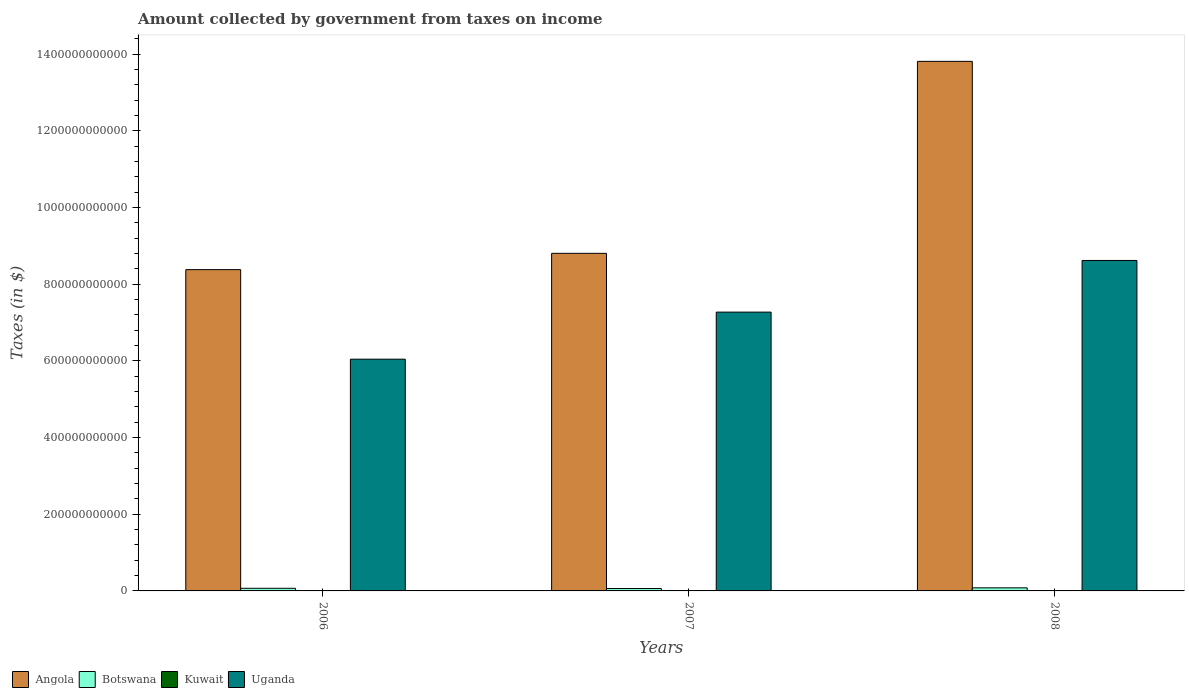Are the number of bars per tick equal to the number of legend labels?
Keep it short and to the point. Yes. What is the label of the 2nd group of bars from the left?
Keep it short and to the point. 2007. What is the amount collected by government from taxes on income in Botswana in 2006?
Offer a very short reply. 6.88e+09. Across all years, what is the maximum amount collected by government from taxes on income in Botswana?
Keep it short and to the point. 8.06e+09. Across all years, what is the minimum amount collected by government from taxes on income in Kuwait?
Your answer should be very brief. 8.20e+07. In which year was the amount collected by government from taxes on income in Botswana maximum?
Offer a terse response. 2008. In which year was the amount collected by government from taxes on income in Botswana minimum?
Keep it short and to the point. 2007. What is the total amount collected by government from taxes on income in Kuwait in the graph?
Give a very brief answer. 3.13e+08. What is the difference between the amount collected by government from taxes on income in Angola in 2007 and that in 2008?
Your answer should be very brief. -5.01e+11. What is the difference between the amount collected by government from taxes on income in Angola in 2008 and the amount collected by government from taxes on income in Kuwait in 2007?
Ensure brevity in your answer.  1.38e+12. What is the average amount collected by government from taxes on income in Botswana per year?
Provide a short and direct response. 7.09e+09. In the year 2007, what is the difference between the amount collected by government from taxes on income in Uganda and amount collected by government from taxes on income in Kuwait?
Your answer should be compact. 7.27e+11. In how many years, is the amount collected by government from taxes on income in Botswana greater than 120000000000 $?
Make the answer very short. 0. What is the ratio of the amount collected by government from taxes on income in Uganda in 2007 to that in 2008?
Your answer should be compact. 0.84. Is the difference between the amount collected by government from taxes on income in Uganda in 2006 and 2007 greater than the difference between the amount collected by government from taxes on income in Kuwait in 2006 and 2007?
Your answer should be compact. No. What is the difference between the highest and the second highest amount collected by government from taxes on income in Uganda?
Provide a succinct answer. 1.35e+11. What is the difference between the highest and the lowest amount collected by government from taxes on income in Angola?
Make the answer very short. 5.43e+11. In how many years, is the amount collected by government from taxes on income in Botswana greater than the average amount collected by government from taxes on income in Botswana taken over all years?
Your response must be concise. 1. Is the sum of the amount collected by government from taxes on income in Botswana in 2007 and 2008 greater than the maximum amount collected by government from taxes on income in Angola across all years?
Provide a succinct answer. No. What does the 4th bar from the left in 2008 represents?
Offer a terse response. Uganda. What does the 4th bar from the right in 2006 represents?
Offer a terse response. Angola. How many bars are there?
Provide a short and direct response. 12. How many years are there in the graph?
Provide a succinct answer. 3. What is the difference between two consecutive major ticks on the Y-axis?
Offer a very short reply. 2.00e+11. Does the graph contain any zero values?
Ensure brevity in your answer.  No. Does the graph contain grids?
Provide a short and direct response. No. Where does the legend appear in the graph?
Offer a terse response. Bottom left. What is the title of the graph?
Make the answer very short. Amount collected by government from taxes on income. Does "Tuvalu" appear as one of the legend labels in the graph?
Give a very brief answer. No. What is the label or title of the Y-axis?
Your answer should be compact. Taxes (in $). What is the Taxes (in $) in Angola in 2006?
Offer a very short reply. 8.38e+11. What is the Taxes (in $) of Botswana in 2006?
Make the answer very short. 6.88e+09. What is the Taxes (in $) in Kuwait in 2006?
Give a very brief answer. 8.20e+07. What is the Taxes (in $) of Uganda in 2006?
Keep it short and to the point. 6.05e+11. What is the Taxes (in $) of Angola in 2007?
Ensure brevity in your answer.  8.81e+11. What is the Taxes (in $) in Botswana in 2007?
Provide a succinct answer. 6.34e+09. What is the Taxes (in $) of Kuwait in 2007?
Your response must be concise. 1.09e+08. What is the Taxes (in $) in Uganda in 2007?
Your answer should be compact. 7.27e+11. What is the Taxes (in $) in Angola in 2008?
Provide a succinct answer. 1.38e+12. What is the Taxes (in $) of Botswana in 2008?
Make the answer very short. 8.06e+09. What is the Taxes (in $) of Kuwait in 2008?
Offer a terse response. 1.22e+08. What is the Taxes (in $) of Uganda in 2008?
Your answer should be compact. 8.62e+11. Across all years, what is the maximum Taxes (in $) of Angola?
Your answer should be very brief. 1.38e+12. Across all years, what is the maximum Taxes (in $) in Botswana?
Give a very brief answer. 8.06e+09. Across all years, what is the maximum Taxes (in $) in Kuwait?
Give a very brief answer. 1.22e+08. Across all years, what is the maximum Taxes (in $) in Uganda?
Provide a succinct answer. 8.62e+11. Across all years, what is the minimum Taxes (in $) of Angola?
Offer a terse response. 8.38e+11. Across all years, what is the minimum Taxes (in $) in Botswana?
Give a very brief answer. 6.34e+09. Across all years, what is the minimum Taxes (in $) of Kuwait?
Provide a short and direct response. 8.20e+07. Across all years, what is the minimum Taxes (in $) of Uganda?
Your response must be concise. 6.05e+11. What is the total Taxes (in $) in Angola in the graph?
Your response must be concise. 3.10e+12. What is the total Taxes (in $) in Botswana in the graph?
Offer a very short reply. 2.13e+1. What is the total Taxes (in $) in Kuwait in the graph?
Your answer should be very brief. 3.13e+08. What is the total Taxes (in $) of Uganda in the graph?
Your response must be concise. 2.19e+12. What is the difference between the Taxes (in $) of Angola in 2006 and that in 2007?
Your answer should be very brief. -4.25e+1. What is the difference between the Taxes (in $) of Botswana in 2006 and that in 2007?
Make the answer very short. 5.33e+08. What is the difference between the Taxes (in $) in Kuwait in 2006 and that in 2007?
Your response must be concise. -2.70e+07. What is the difference between the Taxes (in $) of Uganda in 2006 and that in 2007?
Your answer should be compact. -1.23e+11. What is the difference between the Taxes (in $) in Angola in 2006 and that in 2008?
Ensure brevity in your answer.  -5.43e+11. What is the difference between the Taxes (in $) of Botswana in 2006 and that in 2008?
Give a very brief answer. -1.18e+09. What is the difference between the Taxes (in $) of Kuwait in 2006 and that in 2008?
Ensure brevity in your answer.  -4.00e+07. What is the difference between the Taxes (in $) of Uganda in 2006 and that in 2008?
Ensure brevity in your answer.  -2.58e+11. What is the difference between the Taxes (in $) in Angola in 2007 and that in 2008?
Provide a succinct answer. -5.01e+11. What is the difference between the Taxes (in $) in Botswana in 2007 and that in 2008?
Offer a terse response. -1.72e+09. What is the difference between the Taxes (in $) of Kuwait in 2007 and that in 2008?
Keep it short and to the point. -1.30e+07. What is the difference between the Taxes (in $) in Uganda in 2007 and that in 2008?
Make the answer very short. -1.35e+11. What is the difference between the Taxes (in $) of Angola in 2006 and the Taxes (in $) of Botswana in 2007?
Ensure brevity in your answer.  8.32e+11. What is the difference between the Taxes (in $) in Angola in 2006 and the Taxes (in $) in Kuwait in 2007?
Offer a terse response. 8.38e+11. What is the difference between the Taxes (in $) of Angola in 2006 and the Taxes (in $) of Uganda in 2007?
Your answer should be compact. 1.11e+11. What is the difference between the Taxes (in $) in Botswana in 2006 and the Taxes (in $) in Kuwait in 2007?
Your answer should be very brief. 6.77e+09. What is the difference between the Taxes (in $) of Botswana in 2006 and the Taxes (in $) of Uganda in 2007?
Your response must be concise. -7.21e+11. What is the difference between the Taxes (in $) of Kuwait in 2006 and the Taxes (in $) of Uganda in 2007?
Ensure brevity in your answer.  -7.27e+11. What is the difference between the Taxes (in $) in Angola in 2006 and the Taxes (in $) in Botswana in 2008?
Give a very brief answer. 8.30e+11. What is the difference between the Taxes (in $) in Angola in 2006 and the Taxes (in $) in Kuwait in 2008?
Offer a very short reply. 8.38e+11. What is the difference between the Taxes (in $) of Angola in 2006 and the Taxes (in $) of Uganda in 2008?
Provide a succinct answer. -2.40e+1. What is the difference between the Taxes (in $) in Botswana in 2006 and the Taxes (in $) in Kuwait in 2008?
Your response must be concise. 6.75e+09. What is the difference between the Taxes (in $) of Botswana in 2006 and the Taxes (in $) of Uganda in 2008?
Your response must be concise. -8.55e+11. What is the difference between the Taxes (in $) in Kuwait in 2006 and the Taxes (in $) in Uganda in 2008?
Keep it short and to the point. -8.62e+11. What is the difference between the Taxes (in $) in Angola in 2007 and the Taxes (in $) in Botswana in 2008?
Provide a short and direct response. 8.73e+11. What is the difference between the Taxes (in $) of Angola in 2007 and the Taxes (in $) of Kuwait in 2008?
Your answer should be compact. 8.81e+11. What is the difference between the Taxes (in $) in Angola in 2007 and the Taxes (in $) in Uganda in 2008?
Provide a succinct answer. 1.86e+1. What is the difference between the Taxes (in $) in Botswana in 2007 and the Taxes (in $) in Kuwait in 2008?
Your response must be concise. 6.22e+09. What is the difference between the Taxes (in $) in Botswana in 2007 and the Taxes (in $) in Uganda in 2008?
Your answer should be compact. -8.56e+11. What is the difference between the Taxes (in $) of Kuwait in 2007 and the Taxes (in $) of Uganda in 2008?
Provide a succinct answer. -8.62e+11. What is the average Taxes (in $) in Angola per year?
Offer a very short reply. 1.03e+12. What is the average Taxes (in $) of Botswana per year?
Your answer should be compact. 7.09e+09. What is the average Taxes (in $) of Kuwait per year?
Make the answer very short. 1.04e+08. What is the average Taxes (in $) in Uganda per year?
Your answer should be very brief. 7.31e+11. In the year 2006, what is the difference between the Taxes (in $) of Angola and Taxes (in $) of Botswana?
Provide a succinct answer. 8.31e+11. In the year 2006, what is the difference between the Taxes (in $) of Angola and Taxes (in $) of Kuwait?
Offer a terse response. 8.38e+11. In the year 2006, what is the difference between the Taxes (in $) in Angola and Taxes (in $) in Uganda?
Offer a terse response. 2.34e+11. In the year 2006, what is the difference between the Taxes (in $) of Botswana and Taxes (in $) of Kuwait?
Keep it short and to the point. 6.79e+09. In the year 2006, what is the difference between the Taxes (in $) in Botswana and Taxes (in $) in Uganda?
Ensure brevity in your answer.  -5.98e+11. In the year 2006, what is the difference between the Taxes (in $) in Kuwait and Taxes (in $) in Uganda?
Provide a short and direct response. -6.05e+11. In the year 2007, what is the difference between the Taxes (in $) in Angola and Taxes (in $) in Botswana?
Provide a short and direct response. 8.74e+11. In the year 2007, what is the difference between the Taxes (in $) in Angola and Taxes (in $) in Kuwait?
Your response must be concise. 8.81e+11. In the year 2007, what is the difference between the Taxes (in $) in Angola and Taxes (in $) in Uganda?
Offer a terse response. 1.53e+11. In the year 2007, what is the difference between the Taxes (in $) in Botswana and Taxes (in $) in Kuwait?
Make the answer very short. 6.23e+09. In the year 2007, what is the difference between the Taxes (in $) in Botswana and Taxes (in $) in Uganda?
Keep it short and to the point. -7.21e+11. In the year 2007, what is the difference between the Taxes (in $) in Kuwait and Taxes (in $) in Uganda?
Your response must be concise. -7.27e+11. In the year 2008, what is the difference between the Taxes (in $) in Angola and Taxes (in $) in Botswana?
Your response must be concise. 1.37e+12. In the year 2008, what is the difference between the Taxes (in $) in Angola and Taxes (in $) in Kuwait?
Give a very brief answer. 1.38e+12. In the year 2008, what is the difference between the Taxes (in $) of Angola and Taxes (in $) of Uganda?
Ensure brevity in your answer.  5.19e+11. In the year 2008, what is the difference between the Taxes (in $) in Botswana and Taxes (in $) in Kuwait?
Offer a very short reply. 7.94e+09. In the year 2008, what is the difference between the Taxes (in $) in Botswana and Taxes (in $) in Uganda?
Keep it short and to the point. -8.54e+11. In the year 2008, what is the difference between the Taxes (in $) of Kuwait and Taxes (in $) of Uganda?
Provide a short and direct response. -8.62e+11. What is the ratio of the Taxes (in $) of Angola in 2006 to that in 2007?
Keep it short and to the point. 0.95. What is the ratio of the Taxes (in $) in Botswana in 2006 to that in 2007?
Offer a very short reply. 1.08. What is the ratio of the Taxes (in $) in Kuwait in 2006 to that in 2007?
Offer a terse response. 0.75. What is the ratio of the Taxes (in $) of Uganda in 2006 to that in 2007?
Your answer should be compact. 0.83. What is the ratio of the Taxes (in $) in Angola in 2006 to that in 2008?
Offer a terse response. 0.61. What is the ratio of the Taxes (in $) in Botswana in 2006 to that in 2008?
Provide a short and direct response. 0.85. What is the ratio of the Taxes (in $) in Kuwait in 2006 to that in 2008?
Make the answer very short. 0.67. What is the ratio of the Taxes (in $) of Uganda in 2006 to that in 2008?
Keep it short and to the point. 0.7. What is the ratio of the Taxes (in $) in Angola in 2007 to that in 2008?
Provide a succinct answer. 0.64. What is the ratio of the Taxes (in $) in Botswana in 2007 to that in 2008?
Your answer should be compact. 0.79. What is the ratio of the Taxes (in $) of Kuwait in 2007 to that in 2008?
Offer a very short reply. 0.89. What is the ratio of the Taxes (in $) of Uganda in 2007 to that in 2008?
Offer a very short reply. 0.84. What is the difference between the highest and the second highest Taxes (in $) in Angola?
Provide a succinct answer. 5.01e+11. What is the difference between the highest and the second highest Taxes (in $) in Botswana?
Give a very brief answer. 1.18e+09. What is the difference between the highest and the second highest Taxes (in $) of Kuwait?
Give a very brief answer. 1.30e+07. What is the difference between the highest and the second highest Taxes (in $) of Uganda?
Your answer should be compact. 1.35e+11. What is the difference between the highest and the lowest Taxes (in $) in Angola?
Offer a terse response. 5.43e+11. What is the difference between the highest and the lowest Taxes (in $) in Botswana?
Ensure brevity in your answer.  1.72e+09. What is the difference between the highest and the lowest Taxes (in $) in Kuwait?
Keep it short and to the point. 4.00e+07. What is the difference between the highest and the lowest Taxes (in $) of Uganda?
Make the answer very short. 2.58e+11. 